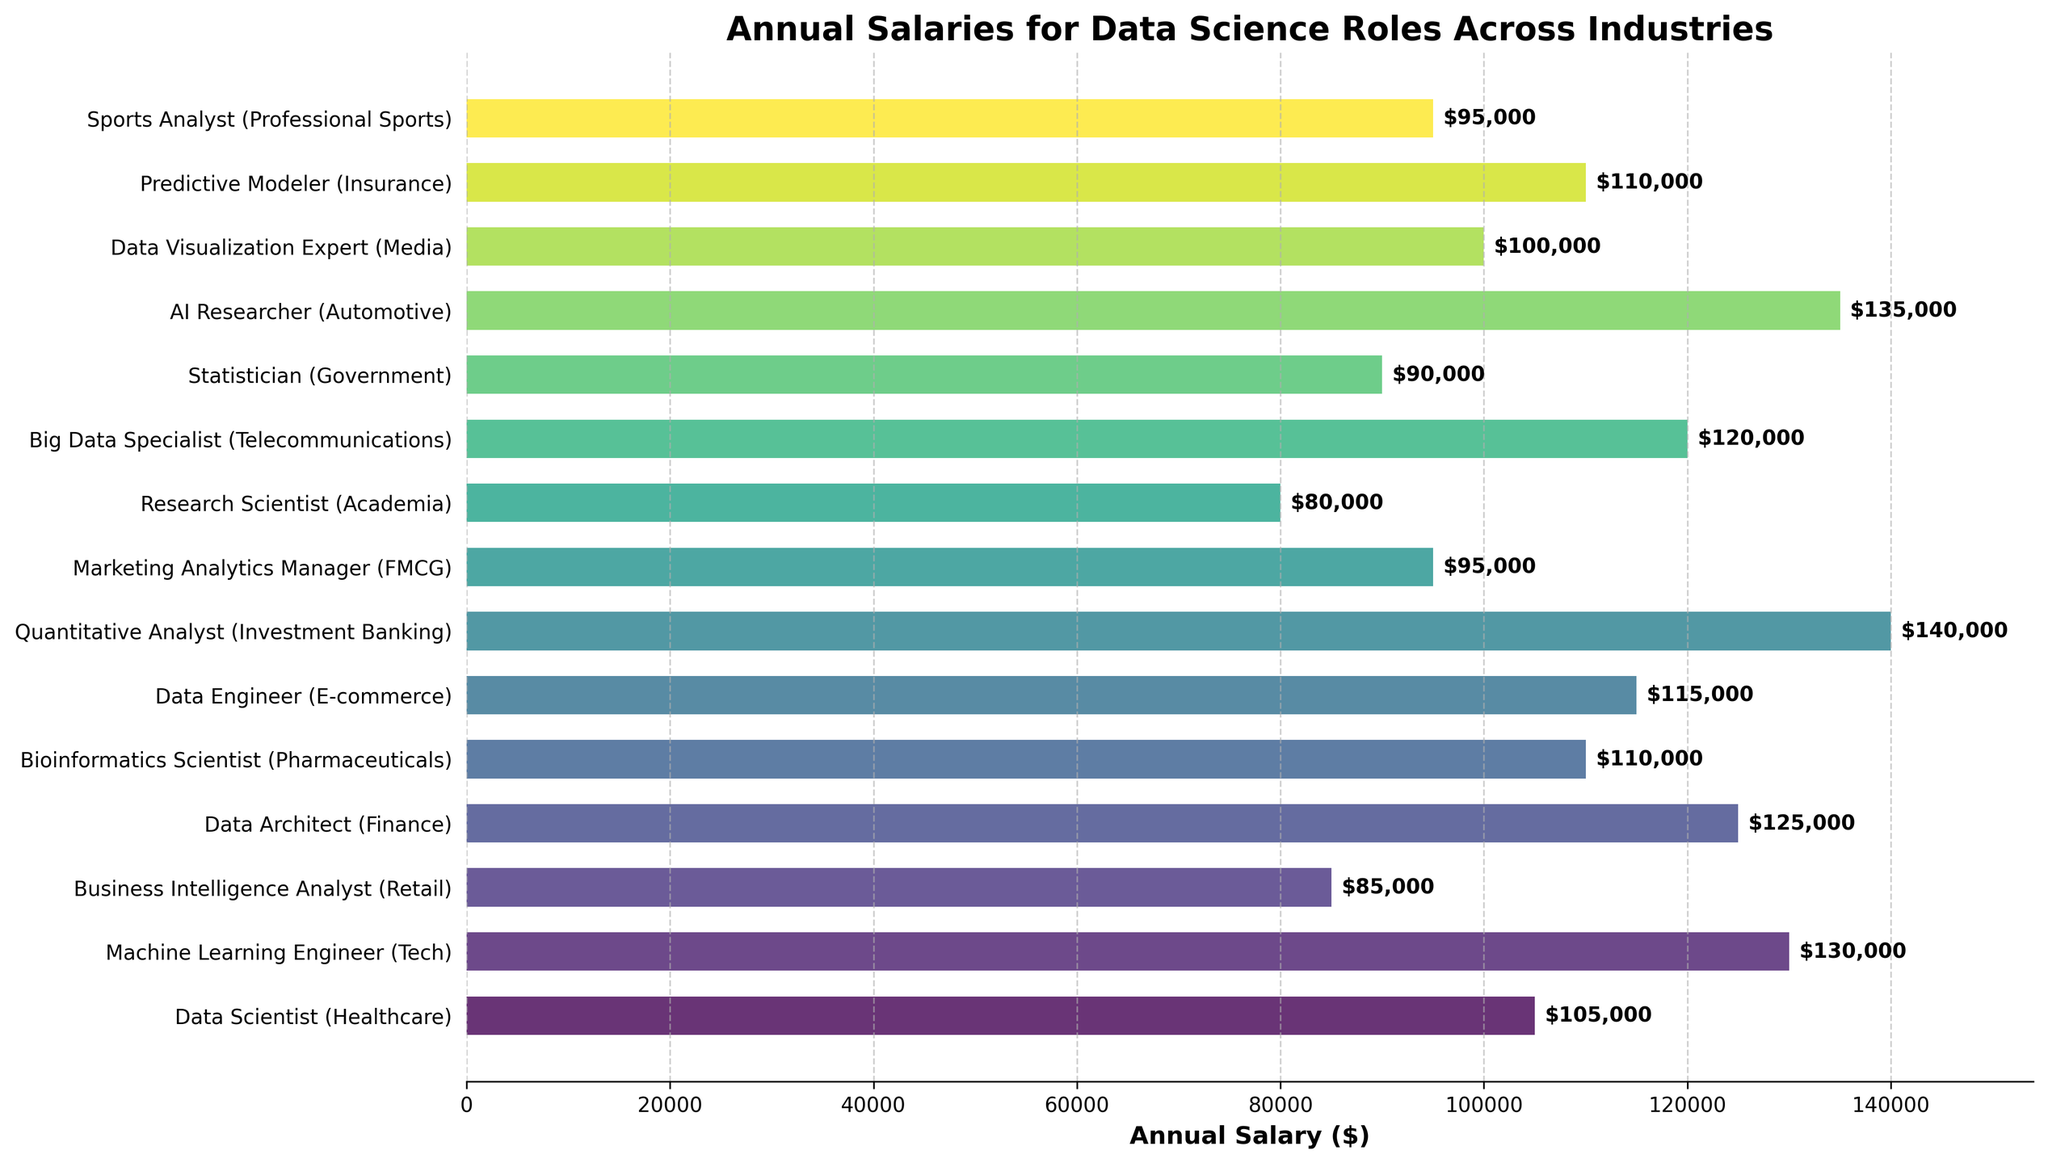What is the highest annual salary among the data science roles? To determine the highest annual salary, you need to look for the tallest bar in the bar chart and check its corresponding salary value at the end of the bar. The highest salary is $140,000 for the Quantitative Analyst (Investment Banking) role.
Answer: $140,000 Which role has the lowest annual salary? To find the role with the lowest annual salary, you need to identify the shortest bar in the bar chart and check its corresponding label and salary value. The Research Scientist (Academia) role has the lowest salary at $80,000.
Answer: Research Scientist (Academia) What is the average annual salary of all the roles? To calculate the average annual salary, add all the salaries together and then divide by the number of roles. The sum is $105,000 (Data Scientist) + $130,000 (ML Engineer) + $85,000 (BI Analyst) + $125,000 (Data Architect) + $110,000 (Bioinformatics Scientist) + $115,000 (Data Engineer) + $140,000 (Quantitative Analyst) + $95,000 (Marketing Analytics Manager) + $80,000 (Research Scientist) + $120,000 (Big Data Specialist) + $90,000 (Statistician) + $135,000 (AI Researcher) + $100,000 (Data Visualization Expert) + $110,000 (Predictive Modeler) + $95,000 (Sports Analyst) = $1,635,000. Dividing this sum by 15 roles equals $109,000.
Answer: $109,000 How much higher is the salary of the highest-paid role compared to the lowest-paid role? To find the difference between the highest and lowest salaries, subtract the lowest salary (Research Scientist, $80,000) from the highest salary (Quantitative Analyst, $140,000). The difference is $140,000 - $80,000 = $60,000.
Answer: $60,000 Which roles have an annual salary greater than $120,000? To identify these roles, look for bars that extend beyond the $120,000 mark and check the corresponding labels. The roles are Machine Learning Engineer (Tech) with $130,000, Data Architect (Finance) with $125,000, Quantitative Analyst (Investment Banking) with $140,000, AI Researcher (Automotive) with $135,000, and Big Data Specialist (Telecommunications) with $120,000.
Answer: Machine Learning Engineer, Data Architect, Quantitative Analyst, AI Researcher, Big Data Specialist 